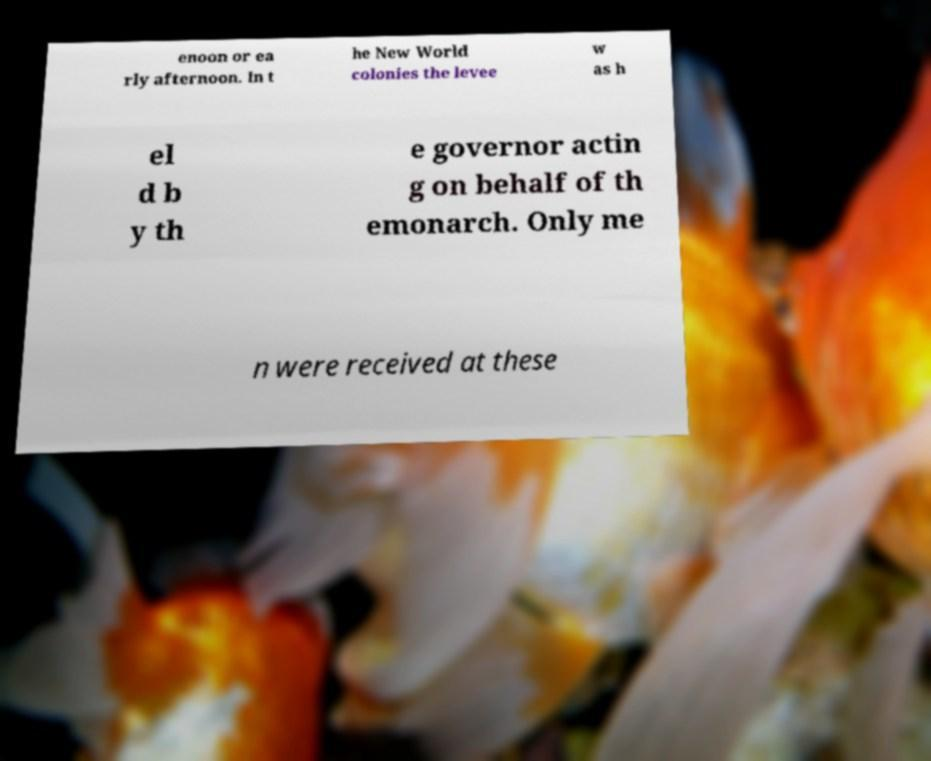For documentation purposes, I need the text within this image transcribed. Could you provide that? enoon or ea rly afternoon. In t he New World colonies the levee w as h el d b y th e governor actin g on behalf of th emonarch. Only me n were received at these 